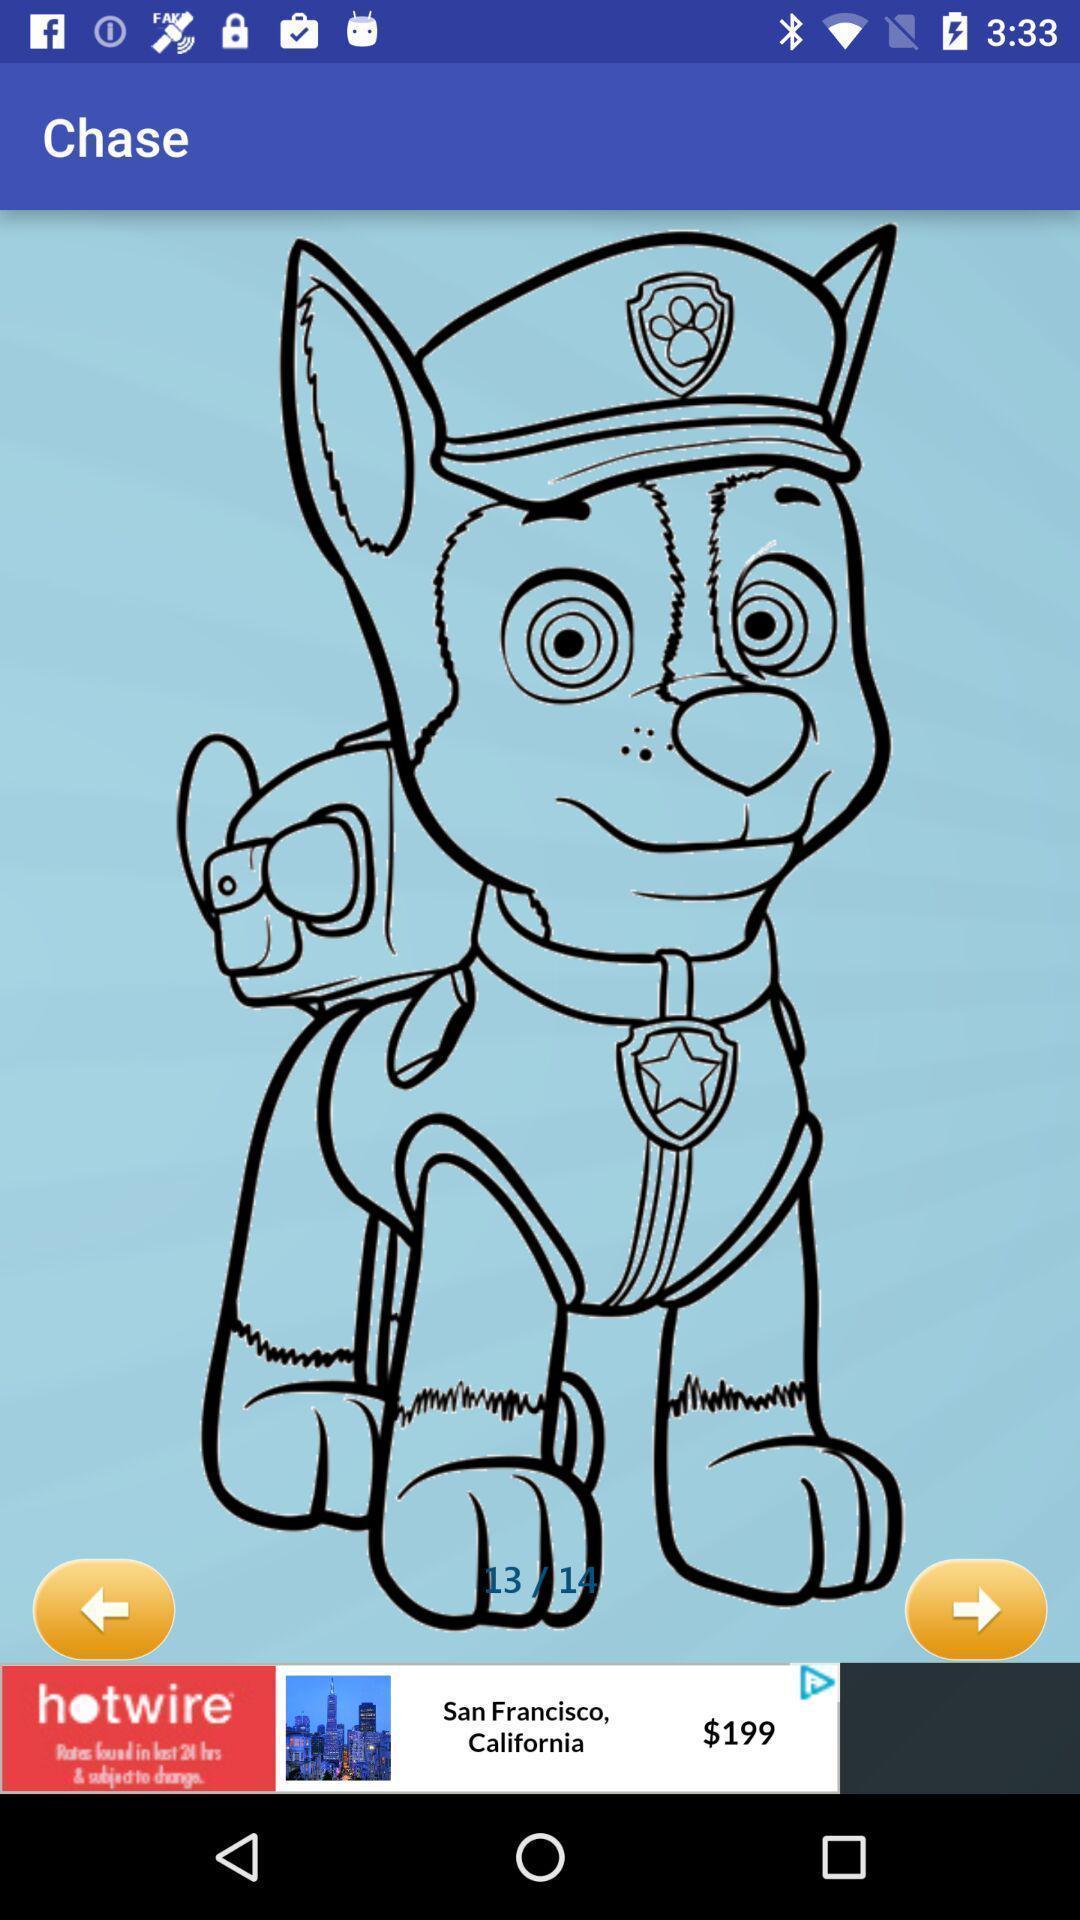Summarize the main components in this picture. Screen shows as chase with an image. 